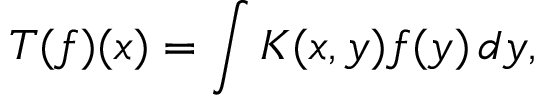<formula> <loc_0><loc_0><loc_500><loc_500>T ( f ) ( x ) = \int K ( x , y ) f ( y ) \, d y ,</formula> 